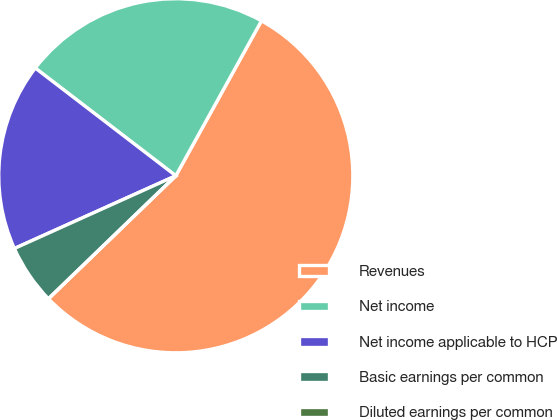<chart> <loc_0><loc_0><loc_500><loc_500><pie_chart><fcel>Revenues<fcel>Net income<fcel>Net income applicable to HCP<fcel>Basic earnings per common<fcel>Diluted earnings per common<nl><fcel>54.75%<fcel>22.63%<fcel>17.15%<fcel>5.48%<fcel>0.0%<nl></chart> 